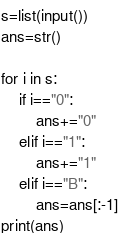<code> <loc_0><loc_0><loc_500><loc_500><_Python_>s=list(input())
ans=str()

for i in s:
    if i=="0":
        ans+="0"
    elif i=="1":
        ans+="1"
    elif i=="B":
        ans=ans[:-1]
print(ans)</code> 